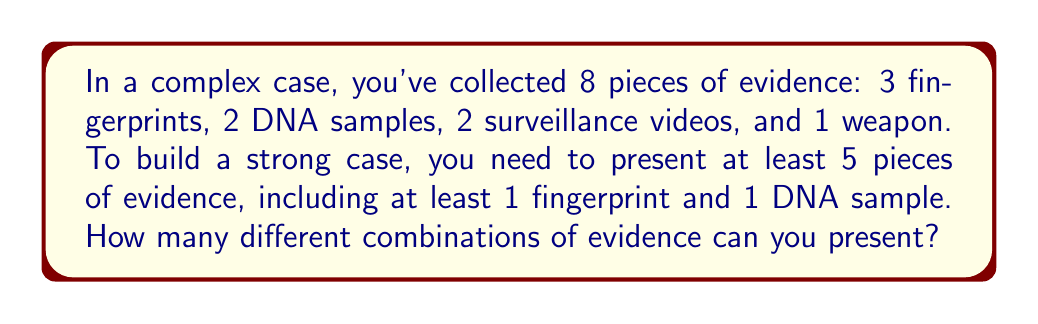Teach me how to tackle this problem. Let's approach this step-by-step:

1) We need to select at least 5 pieces of evidence, which means we can select 5, 6, 7, or 8 pieces.

2) We must include at least 1 fingerprint and 1 DNA sample. Let's consider these as our starting point.

3) Now, we need to calculate the number of ways to select the remaining pieces:

   a) If we select 5 pieces total:
      We've already selected 2 (1 fingerprint and 1 DNA), so we need to select 3 more from the remaining 6 items.
      This can be done in $\binom{6}{3}$ ways.

   b) If we select 6 pieces total:
      We need to select 4 more from the remaining 6 items: $\binom{6}{4}$ ways.

   c) If we select 7 pieces total:
      We need to select 5 more from the remaining 6 items: $\binom{6}{5}$ ways.

   d) If we select all 8 pieces:
      There's only $\binom{6}{6} = 1$ way to do this.

4) However, we've overcounted. For each of these selections, we could have chosen more than one fingerprint or DNA sample. We need to account for this:

   - We can choose 1, 2, or 3 fingerprints: $\binom{3}{1} + \binom{3}{2} + \binom{3}{3} = 3 + 3 + 1 = 7$ ways
   - We can choose 1 or 2 DNA samples: $\binom{2}{1} + \binom{2}{2} = 2 + 1 = 3$ ways

5) By the multiplication principle, for each selection of the remaining items, we have $7 \times 3 = 21$ ways to choose the fingerprints and DNA samples.

6) Therefore, the total number of combinations is:

   $$21 \times (\binom{6}{3} + \binom{6}{4} + \binom{6}{5} + \binom{6}{6})$$

7) Calculating:
   $$21 \times (20 + 15 + 6 + 1) = 21 \times 42 = 882$$
Answer: 882 combinations 